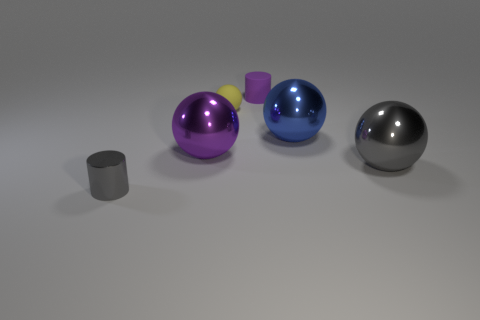There is a big shiny thing that is the same color as the small metal object; what shape is it?
Give a very brief answer. Sphere. Is the color of the small shiny thing the same as the thing on the right side of the big blue shiny sphere?
Your response must be concise. Yes. What number of large things are the same color as the rubber cylinder?
Your answer should be compact. 1. Are there the same number of small purple cylinders that are to the right of the small purple matte thing and tiny gray things?
Your response must be concise. No. Is there a purple cylinder that is in front of the large shiny thing to the right of the large object behind the purple shiny thing?
Offer a terse response. No. The other object that is the same material as the small purple thing is what color?
Keep it short and to the point. Yellow. Does the big metallic thing that is right of the blue metallic thing have the same color as the small metallic cylinder?
Give a very brief answer. Yes. What number of balls are small shiny objects or purple metallic things?
Provide a short and direct response. 1. How big is the cylinder that is in front of the cylinder on the right side of the gray thing on the left side of the gray sphere?
Offer a terse response. Small. What is the shape of the purple thing that is the same size as the blue metal object?
Provide a succinct answer. Sphere. 